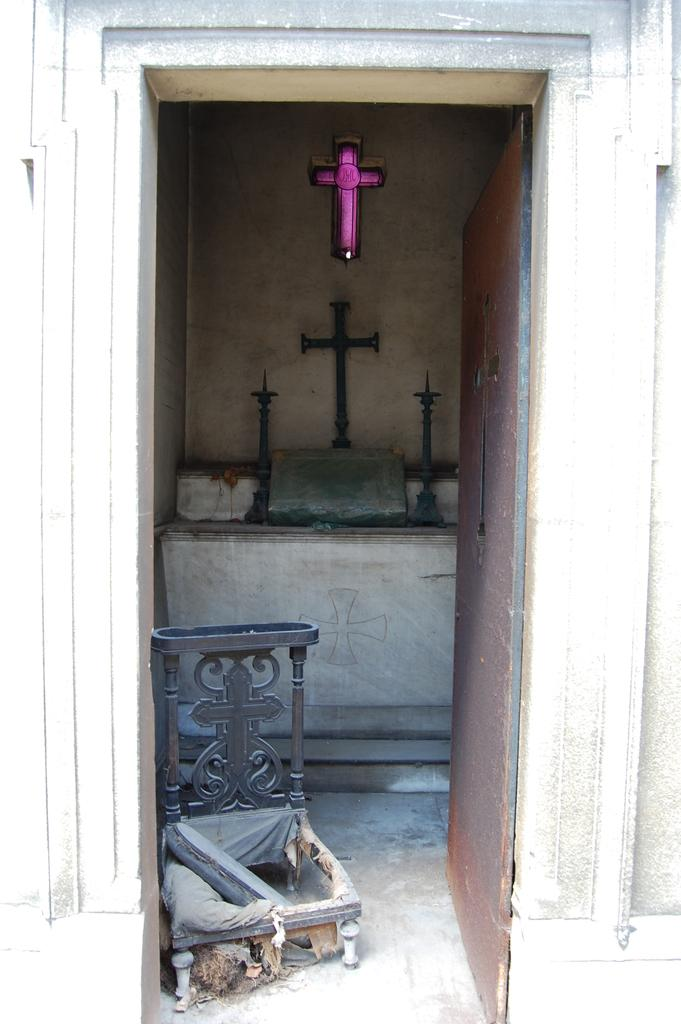What religious symbols can be seen in the image? There are holy cross symbols in the image. What architectural feature is present in the image? There is a door in the image. What type of structure is depicted in the image? There is a wall in the image. What else can be seen in the image besides the religious symbols, door, and wall? There is an object in the image. What is the tendency of the brother in the image? There is no brother present in the image, so it is not possible to determine any tendencies. 